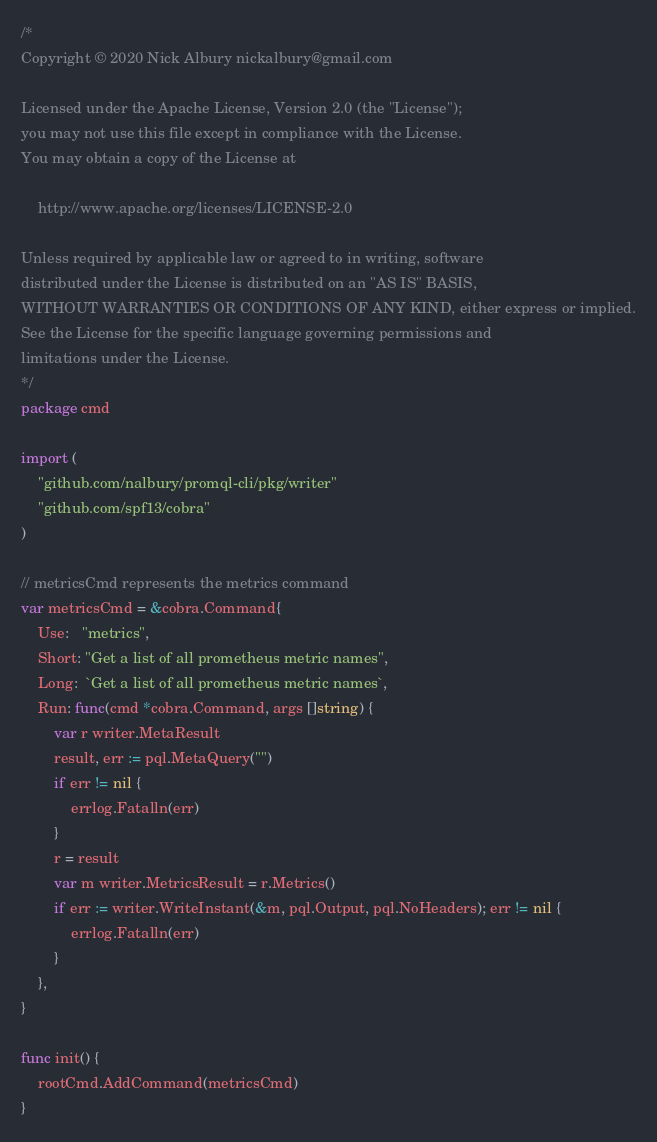Convert code to text. <code><loc_0><loc_0><loc_500><loc_500><_Go_>/*
Copyright © 2020 Nick Albury nickalbury@gmail.com

Licensed under the Apache License, Version 2.0 (the "License");
you may not use this file except in compliance with the License.
You may obtain a copy of the License at

    http://www.apache.org/licenses/LICENSE-2.0

Unless required by applicable law or agreed to in writing, software
distributed under the License is distributed on an "AS IS" BASIS,
WITHOUT WARRANTIES OR CONDITIONS OF ANY KIND, either express or implied.
See the License for the specific language governing permissions and
limitations under the License.
*/
package cmd

import (
	"github.com/nalbury/promql-cli/pkg/writer"
	"github.com/spf13/cobra"
)

// metricsCmd represents the metrics command
var metricsCmd = &cobra.Command{
	Use:   "metrics",
	Short: "Get a list of all prometheus metric names",
	Long:  `Get a list of all prometheus metric names`,
	Run: func(cmd *cobra.Command, args []string) {
		var r writer.MetaResult
		result, err := pql.MetaQuery("")
		if err != nil {
			errlog.Fatalln(err)
		}
		r = result
		var m writer.MetricsResult = r.Metrics()
		if err := writer.WriteInstant(&m, pql.Output, pql.NoHeaders); err != nil {
			errlog.Fatalln(err)
		}
	},
}

func init() {
	rootCmd.AddCommand(metricsCmd)
}
</code> 